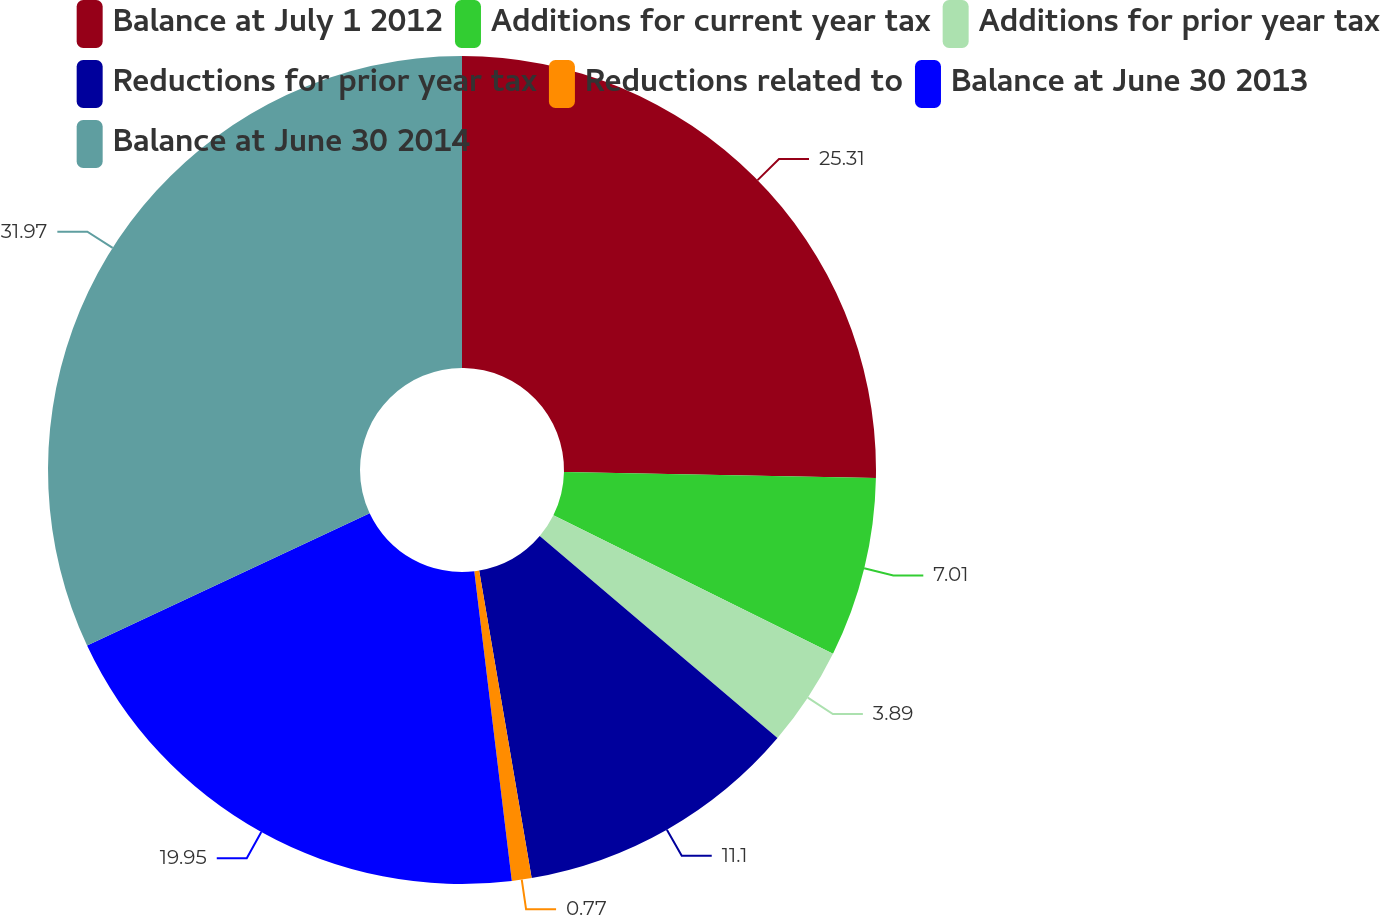<chart> <loc_0><loc_0><loc_500><loc_500><pie_chart><fcel>Balance at July 1 2012<fcel>Additions for current year tax<fcel>Additions for prior year tax<fcel>Reductions for prior year tax<fcel>Reductions related to<fcel>Balance at June 30 2013<fcel>Balance at June 30 2014<nl><fcel>25.31%<fcel>7.01%<fcel>3.89%<fcel>11.1%<fcel>0.77%<fcel>19.95%<fcel>31.97%<nl></chart> 